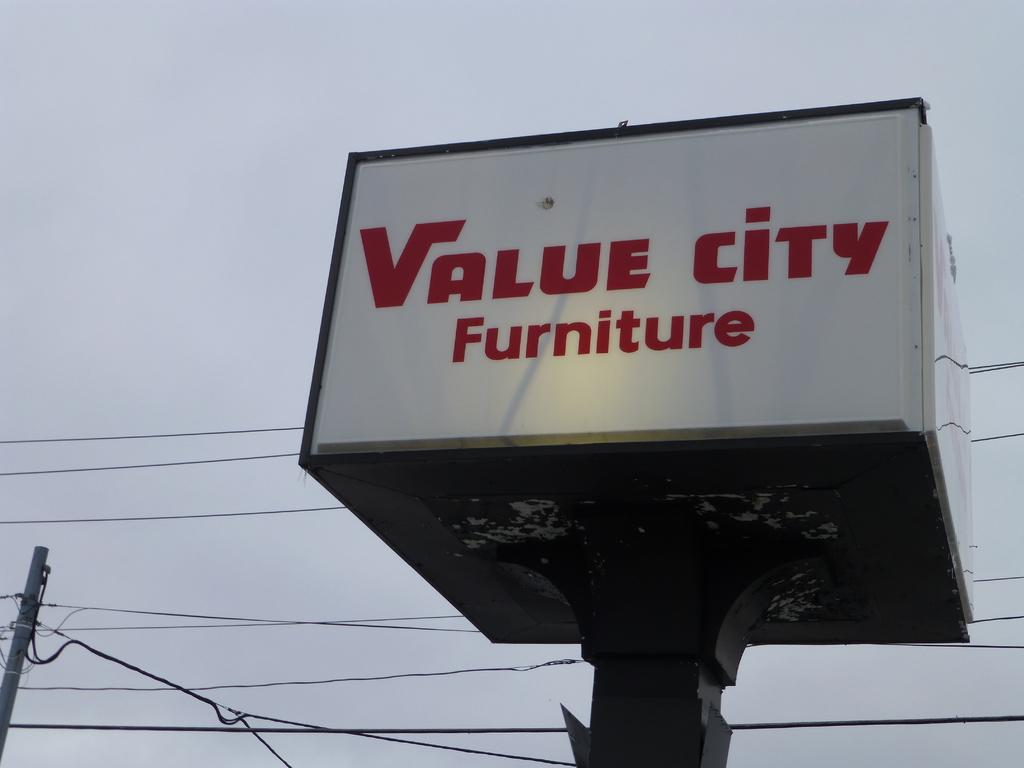<image>
Write a terse but informative summary of the picture. A white and red sign for Value City Furniture. 